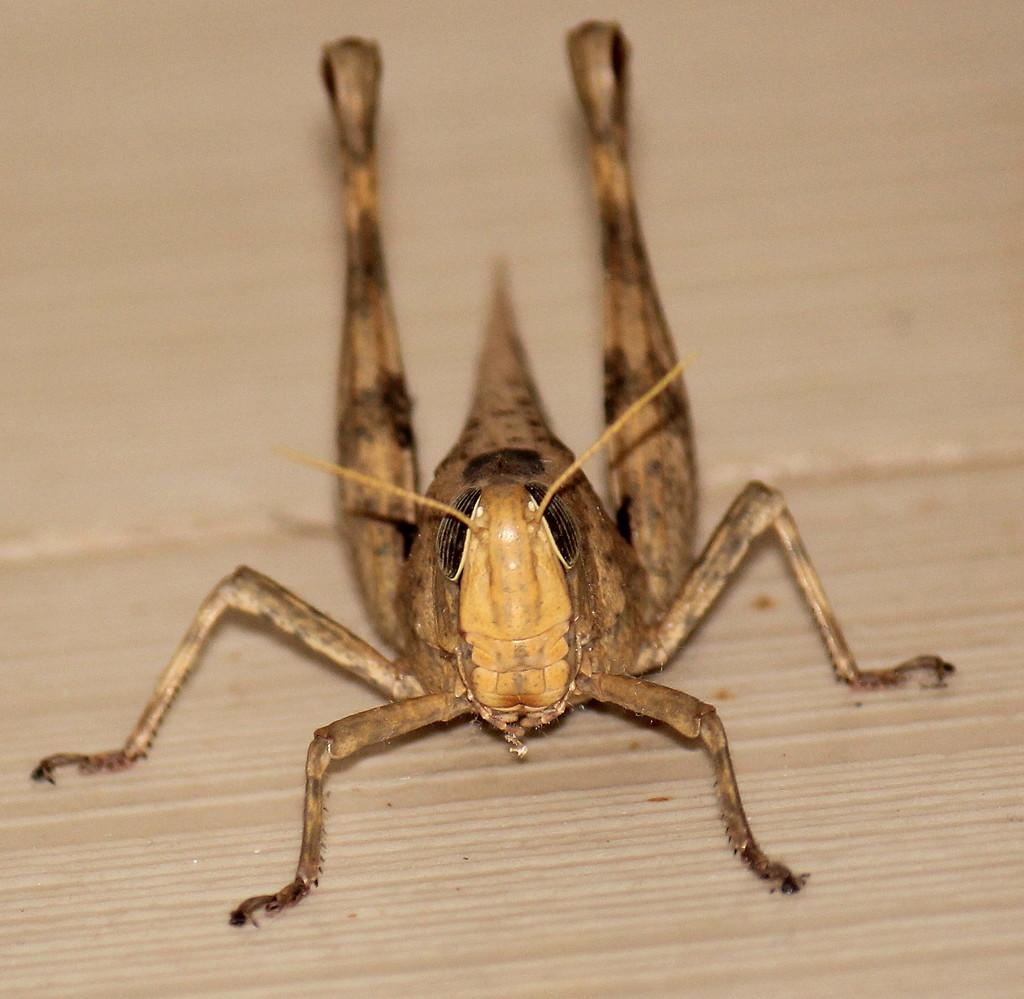What type of creature can be seen in the image? There is an insect in the image. What is the insect resting on in the image? The insect is on a wooden surface. How does the worm stop its account in the image? There is no worm or account present in the image; it only features an insect on a wooden surface. 